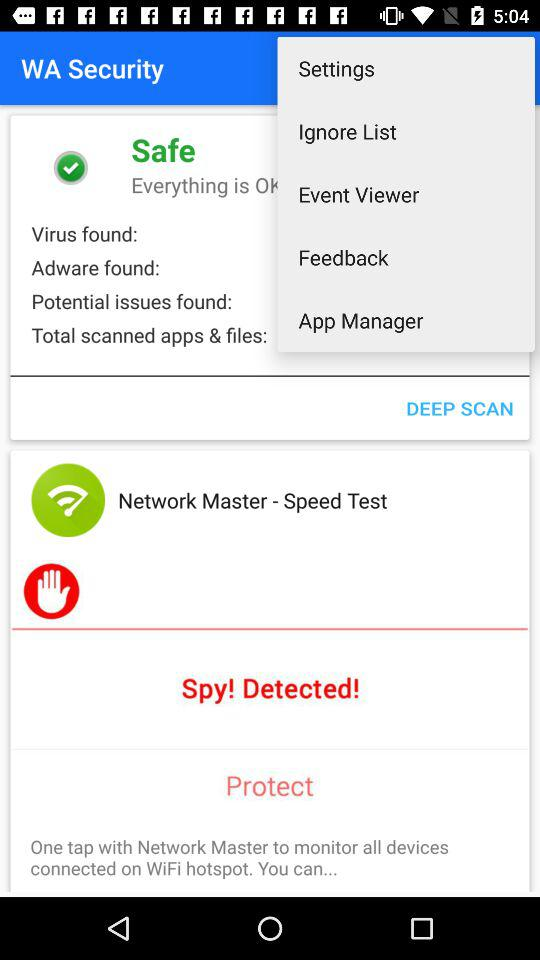On what date was the security activated? The security was activated on December 06. 